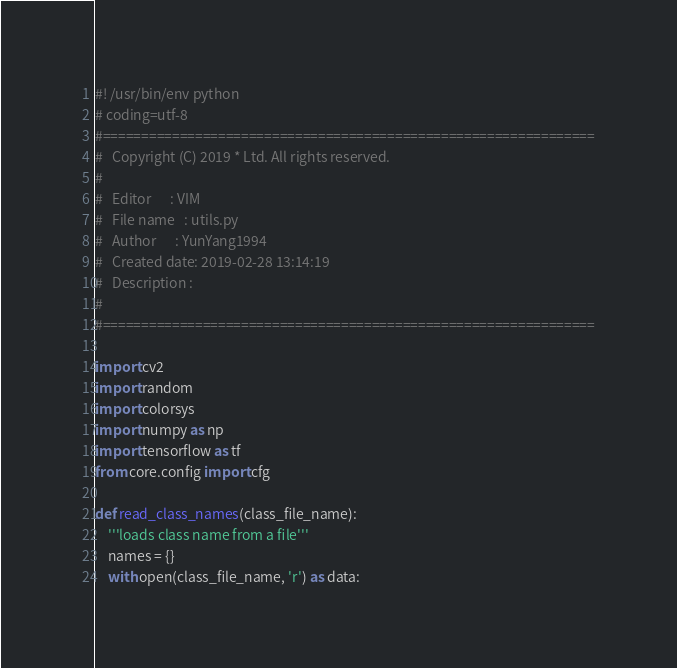<code> <loc_0><loc_0><loc_500><loc_500><_Python_>#! /usr/bin/env python
# coding=utf-8
#================================================================
#   Copyright (C) 2019 * Ltd. All rights reserved.
#
#   Editor      : VIM
#   File name   : utils.py
#   Author      : YunYang1994
#   Created date: 2019-02-28 13:14:19
#   Description :
#
#================================================================

import cv2
import random
import colorsys
import numpy as np
import tensorflow as tf
from core.config import cfg

def read_class_names(class_file_name):
    '''loads class name from a file'''
    names = {}
    with open(class_file_name, 'r') as data:</code> 